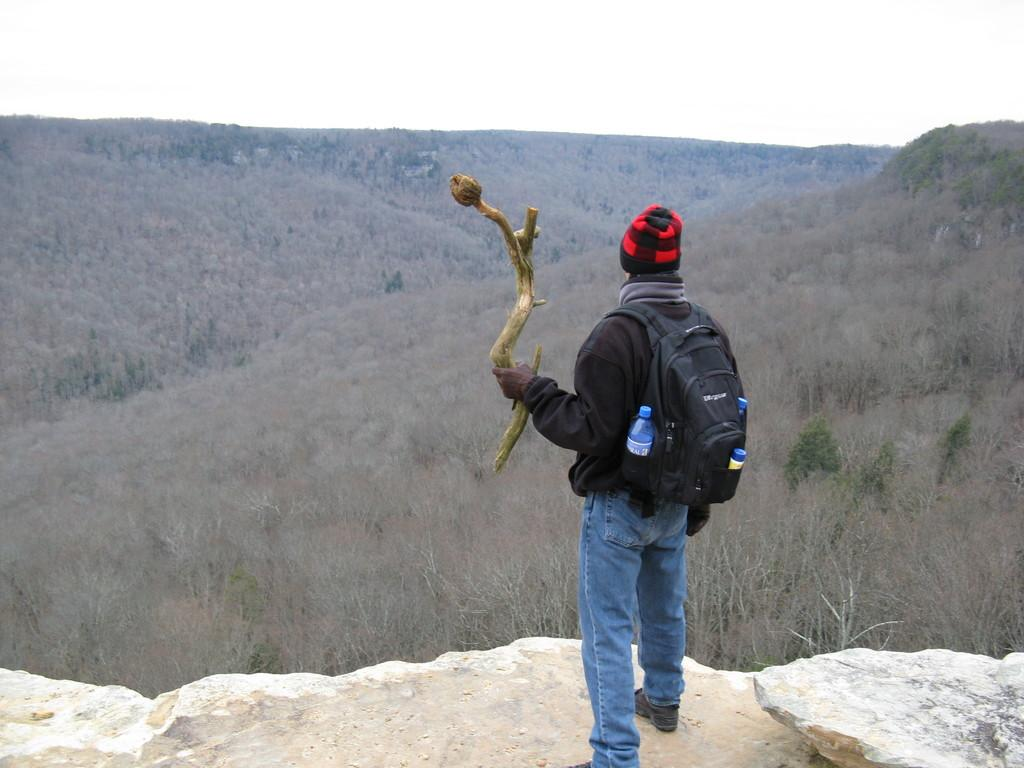What is the main subject of the image? The main subject of the image is a man standing. What is the man wearing on his shoulders? The man is wearing a black color bag on his shoulders. What can be seen in the background of the image? There are plants and the sky visible in the background of the image. Can you tell me how many basketballs are in the man's bag? There is no basketball mentioned or visible in the image. What type of straw is sticking out of the man's bag? There is no straw visible in the image. 